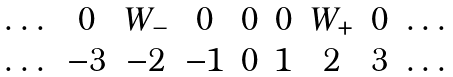Convert formula to latex. <formula><loc_0><loc_0><loc_500><loc_500>\begin{matrix} \dots & 0 & W _ { - } & 0 & 0 & 0 & W _ { + } & 0 & \dots \\ \dots & - 3 & - 2 & - 1 & 0 & 1 & 2 & 3 & \dots \end{matrix}</formula> 